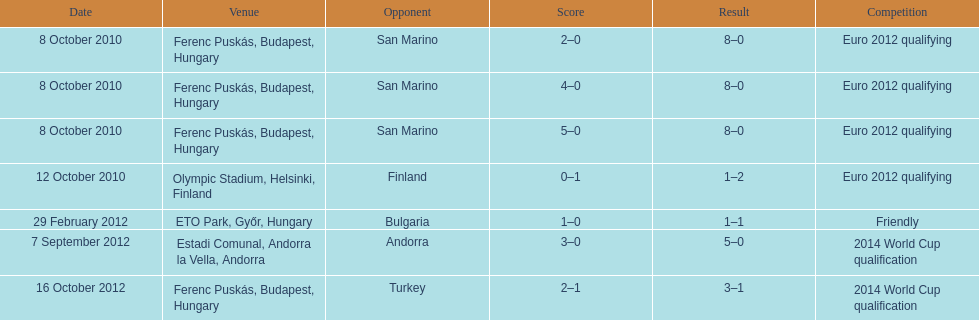How many games did he score but his team lost? 1. 